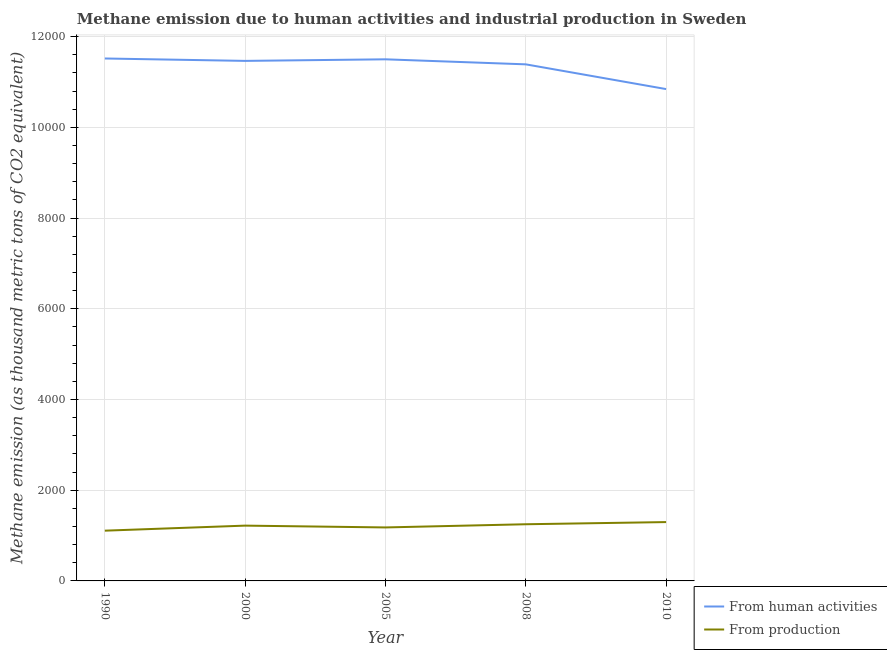How many different coloured lines are there?
Your answer should be compact. 2. Does the line corresponding to amount of emissions generated from industries intersect with the line corresponding to amount of emissions from human activities?
Give a very brief answer. No. What is the amount of emissions from human activities in 2000?
Provide a succinct answer. 1.15e+04. Across all years, what is the maximum amount of emissions from human activities?
Ensure brevity in your answer.  1.15e+04. Across all years, what is the minimum amount of emissions from human activities?
Provide a short and direct response. 1.08e+04. In which year was the amount of emissions generated from industries minimum?
Keep it short and to the point. 1990. What is the total amount of emissions generated from industries in the graph?
Offer a terse response. 6054. What is the difference between the amount of emissions generated from industries in 1990 and that in 2000?
Give a very brief answer. -111.2. What is the difference between the amount of emissions generated from industries in 2010 and the amount of emissions from human activities in 2005?
Keep it short and to the point. -1.02e+04. What is the average amount of emissions from human activities per year?
Your response must be concise. 1.13e+04. In the year 2005, what is the difference between the amount of emissions generated from industries and amount of emissions from human activities?
Ensure brevity in your answer.  -1.03e+04. What is the ratio of the amount of emissions generated from industries in 1990 to that in 2008?
Provide a succinct answer. 0.89. Is the difference between the amount of emissions from human activities in 2008 and 2010 greater than the difference between the amount of emissions generated from industries in 2008 and 2010?
Offer a terse response. Yes. What is the difference between the highest and the second highest amount of emissions generated from industries?
Provide a short and direct response. 47.8. What is the difference between the highest and the lowest amount of emissions generated from industries?
Your answer should be compact. 189.4. Is the amount of emissions from human activities strictly less than the amount of emissions generated from industries over the years?
Your answer should be compact. No. How many lines are there?
Offer a very short reply. 2. What is the difference between two consecutive major ticks on the Y-axis?
Your answer should be very brief. 2000. How many legend labels are there?
Make the answer very short. 2. What is the title of the graph?
Your answer should be compact. Methane emission due to human activities and industrial production in Sweden. What is the label or title of the Y-axis?
Your answer should be very brief. Methane emission (as thousand metric tons of CO2 equivalent). What is the Methane emission (as thousand metric tons of CO2 equivalent) in From human activities in 1990?
Offer a very short reply. 1.15e+04. What is the Methane emission (as thousand metric tons of CO2 equivalent) in From production in 1990?
Your answer should be very brief. 1108.1. What is the Methane emission (as thousand metric tons of CO2 equivalent) of From human activities in 2000?
Keep it short and to the point. 1.15e+04. What is the Methane emission (as thousand metric tons of CO2 equivalent) in From production in 2000?
Keep it short and to the point. 1219.3. What is the Methane emission (as thousand metric tons of CO2 equivalent) in From human activities in 2005?
Provide a short and direct response. 1.15e+04. What is the Methane emission (as thousand metric tons of CO2 equivalent) in From production in 2005?
Your answer should be compact. 1179.4. What is the Methane emission (as thousand metric tons of CO2 equivalent) in From human activities in 2008?
Provide a succinct answer. 1.14e+04. What is the Methane emission (as thousand metric tons of CO2 equivalent) in From production in 2008?
Your answer should be compact. 1249.7. What is the Methane emission (as thousand metric tons of CO2 equivalent) in From human activities in 2010?
Provide a succinct answer. 1.08e+04. What is the Methane emission (as thousand metric tons of CO2 equivalent) of From production in 2010?
Your answer should be compact. 1297.5. Across all years, what is the maximum Methane emission (as thousand metric tons of CO2 equivalent) of From human activities?
Give a very brief answer. 1.15e+04. Across all years, what is the maximum Methane emission (as thousand metric tons of CO2 equivalent) in From production?
Offer a terse response. 1297.5. Across all years, what is the minimum Methane emission (as thousand metric tons of CO2 equivalent) of From human activities?
Provide a short and direct response. 1.08e+04. Across all years, what is the minimum Methane emission (as thousand metric tons of CO2 equivalent) of From production?
Your answer should be very brief. 1108.1. What is the total Methane emission (as thousand metric tons of CO2 equivalent) of From human activities in the graph?
Your response must be concise. 5.67e+04. What is the total Methane emission (as thousand metric tons of CO2 equivalent) of From production in the graph?
Offer a terse response. 6054. What is the difference between the Methane emission (as thousand metric tons of CO2 equivalent) of From production in 1990 and that in 2000?
Give a very brief answer. -111.2. What is the difference between the Methane emission (as thousand metric tons of CO2 equivalent) of From human activities in 1990 and that in 2005?
Your response must be concise. 18.4. What is the difference between the Methane emission (as thousand metric tons of CO2 equivalent) in From production in 1990 and that in 2005?
Make the answer very short. -71.3. What is the difference between the Methane emission (as thousand metric tons of CO2 equivalent) in From human activities in 1990 and that in 2008?
Your response must be concise. 129.2. What is the difference between the Methane emission (as thousand metric tons of CO2 equivalent) of From production in 1990 and that in 2008?
Keep it short and to the point. -141.6. What is the difference between the Methane emission (as thousand metric tons of CO2 equivalent) in From human activities in 1990 and that in 2010?
Ensure brevity in your answer.  674.5. What is the difference between the Methane emission (as thousand metric tons of CO2 equivalent) of From production in 1990 and that in 2010?
Your answer should be compact. -189.4. What is the difference between the Methane emission (as thousand metric tons of CO2 equivalent) in From human activities in 2000 and that in 2005?
Offer a very short reply. -34.6. What is the difference between the Methane emission (as thousand metric tons of CO2 equivalent) of From production in 2000 and that in 2005?
Make the answer very short. 39.9. What is the difference between the Methane emission (as thousand metric tons of CO2 equivalent) in From human activities in 2000 and that in 2008?
Provide a short and direct response. 76.2. What is the difference between the Methane emission (as thousand metric tons of CO2 equivalent) in From production in 2000 and that in 2008?
Provide a short and direct response. -30.4. What is the difference between the Methane emission (as thousand metric tons of CO2 equivalent) of From human activities in 2000 and that in 2010?
Offer a very short reply. 621.5. What is the difference between the Methane emission (as thousand metric tons of CO2 equivalent) of From production in 2000 and that in 2010?
Make the answer very short. -78.2. What is the difference between the Methane emission (as thousand metric tons of CO2 equivalent) in From human activities in 2005 and that in 2008?
Provide a succinct answer. 110.8. What is the difference between the Methane emission (as thousand metric tons of CO2 equivalent) of From production in 2005 and that in 2008?
Your response must be concise. -70.3. What is the difference between the Methane emission (as thousand metric tons of CO2 equivalent) of From human activities in 2005 and that in 2010?
Offer a very short reply. 656.1. What is the difference between the Methane emission (as thousand metric tons of CO2 equivalent) in From production in 2005 and that in 2010?
Offer a very short reply. -118.1. What is the difference between the Methane emission (as thousand metric tons of CO2 equivalent) of From human activities in 2008 and that in 2010?
Offer a terse response. 545.3. What is the difference between the Methane emission (as thousand metric tons of CO2 equivalent) in From production in 2008 and that in 2010?
Make the answer very short. -47.8. What is the difference between the Methane emission (as thousand metric tons of CO2 equivalent) in From human activities in 1990 and the Methane emission (as thousand metric tons of CO2 equivalent) in From production in 2000?
Offer a terse response. 1.03e+04. What is the difference between the Methane emission (as thousand metric tons of CO2 equivalent) in From human activities in 1990 and the Methane emission (as thousand metric tons of CO2 equivalent) in From production in 2005?
Ensure brevity in your answer.  1.03e+04. What is the difference between the Methane emission (as thousand metric tons of CO2 equivalent) of From human activities in 1990 and the Methane emission (as thousand metric tons of CO2 equivalent) of From production in 2008?
Your response must be concise. 1.03e+04. What is the difference between the Methane emission (as thousand metric tons of CO2 equivalent) of From human activities in 1990 and the Methane emission (as thousand metric tons of CO2 equivalent) of From production in 2010?
Keep it short and to the point. 1.02e+04. What is the difference between the Methane emission (as thousand metric tons of CO2 equivalent) of From human activities in 2000 and the Methane emission (as thousand metric tons of CO2 equivalent) of From production in 2005?
Offer a terse response. 1.03e+04. What is the difference between the Methane emission (as thousand metric tons of CO2 equivalent) in From human activities in 2000 and the Methane emission (as thousand metric tons of CO2 equivalent) in From production in 2008?
Ensure brevity in your answer.  1.02e+04. What is the difference between the Methane emission (as thousand metric tons of CO2 equivalent) of From human activities in 2000 and the Methane emission (as thousand metric tons of CO2 equivalent) of From production in 2010?
Give a very brief answer. 1.02e+04. What is the difference between the Methane emission (as thousand metric tons of CO2 equivalent) of From human activities in 2005 and the Methane emission (as thousand metric tons of CO2 equivalent) of From production in 2008?
Keep it short and to the point. 1.03e+04. What is the difference between the Methane emission (as thousand metric tons of CO2 equivalent) of From human activities in 2005 and the Methane emission (as thousand metric tons of CO2 equivalent) of From production in 2010?
Give a very brief answer. 1.02e+04. What is the difference between the Methane emission (as thousand metric tons of CO2 equivalent) in From human activities in 2008 and the Methane emission (as thousand metric tons of CO2 equivalent) in From production in 2010?
Offer a very short reply. 1.01e+04. What is the average Methane emission (as thousand metric tons of CO2 equivalent) in From human activities per year?
Keep it short and to the point. 1.13e+04. What is the average Methane emission (as thousand metric tons of CO2 equivalent) in From production per year?
Your response must be concise. 1210.8. In the year 1990, what is the difference between the Methane emission (as thousand metric tons of CO2 equivalent) in From human activities and Methane emission (as thousand metric tons of CO2 equivalent) in From production?
Provide a succinct answer. 1.04e+04. In the year 2000, what is the difference between the Methane emission (as thousand metric tons of CO2 equivalent) of From human activities and Methane emission (as thousand metric tons of CO2 equivalent) of From production?
Give a very brief answer. 1.02e+04. In the year 2005, what is the difference between the Methane emission (as thousand metric tons of CO2 equivalent) of From human activities and Methane emission (as thousand metric tons of CO2 equivalent) of From production?
Ensure brevity in your answer.  1.03e+04. In the year 2008, what is the difference between the Methane emission (as thousand metric tons of CO2 equivalent) of From human activities and Methane emission (as thousand metric tons of CO2 equivalent) of From production?
Provide a succinct answer. 1.01e+04. In the year 2010, what is the difference between the Methane emission (as thousand metric tons of CO2 equivalent) of From human activities and Methane emission (as thousand metric tons of CO2 equivalent) of From production?
Your answer should be compact. 9547.3. What is the ratio of the Methane emission (as thousand metric tons of CO2 equivalent) in From production in 1990 to that in 2000?
Offer a very short reply. 0.91. What is the ratio of the Methane emission (as thousand metric tons of CO2 equivalent) in From human activities in 1990 to that in 2005?
Keep it short and to the point. 1. What is the ratio of the Methane emission (as thousand metric tons of CO2 equivalent) of From production in 1990 to that in 2005?
Ensure brevity in your answer.  0.94. What is the ratio of the Methane emission (as thousand metric tons of CO2 equivalent) in From human activities in 1990 to that in 2008?
Keep it short and to the point. 1.01. What is the ratio of the Methane emission (as thousand metric tons of CO2 equivalent) in From production in 1990 to that in 2008?
Your response must be concise. 0.89. What is the ratio of the Methane emission (as thousand metric tons of CO2 equivalent) in From human activities in 1990 to that in 2010?
Keep it short and to the point. 1.06. What is the ratio of the Methane emission (as thousand metric tons of CO2 equivalent) of From production in 1990 to that in 2010?
Your response must be concise. 0.85. What is the ratio of the Methane emission (as thousand metric tons of CO2 equivalent) in From production in 2000 to that in 2005?
Your answer should be compact. 1.03. What is the ratio of the Methane emission (as thousand metric tons of CO2 equivalent) in From human activities in 2000 to that in 2008?
Your answer should be very brief. 1.01. What is the ratio of the Methane emission (as thousand metric tons of CO2 equivalent) of From production in 2000 to that in 2008?
Offer a very short reply. 0.98. What is the ratio of the Methane emission (as thousand metric tons of CO2 equivalent) of From human activities in 2000 to that in 2010?
Make the answer very short. 1.06. What is the ratio of the Methane emission (as thousand metric tons of CO2 equivalent) of From production in 2000 to that in 2010?
Offer a very short reply. 0.94. What is the ratio of the Methane emission (as thousand metric tons of CO2 equivalent) in From human activities in 2005 to that in 2008?
Keep it short and to the point. 1.01. What is the ratio of the Methane emission (as thousand metric tons of CO2 equivalent) in From production in 2005 to that in 2008?
Your response must be concise. 0.94. What is the ratio of the Methane emission (as thousand metric tons of CO2 equivalent) of From human activities in 2005 to that in 2010?
Your answer should be compact. 1.06. What is the ratio of the Methane emission (as thousand metric tons of CO2 equivalent) in From production in 2005 to that in 2010?
Your answer should be very brief. 0.91. What is the ratio of the Methane emission (as thousand metric tons of CO2 equivalent) of From human activities in 2008 to that in 2010?
Your answer should be very brief. 1.05. What is the ratio of the Methane emission (as thousand metric tons of CO2 equivalent) of From production in 2008 to that in 2010?
Your response must be concise. 0.96. What is the difference between the highest and the second highest Methane emission (as thousand metric tons of CO2 equivalent) in From human activities?
Give a very brief answer. 18.4. What is the difference between the highest and the second highest Methane emission (as thousand metric tons of CO2 equivalent) in From production?
Keep it short and to the point. 47.8. What is the difference between the highest and the lowest Methane emission (as thousand metric tons of CO2 equivalent) in From human activities?
Your response must be concise. 674.5. What is the difference between the highest and the lowest Methane emission (as thousand metric tons of CO2 equivalent) in From production?
Your response must be concise. 189.4. 